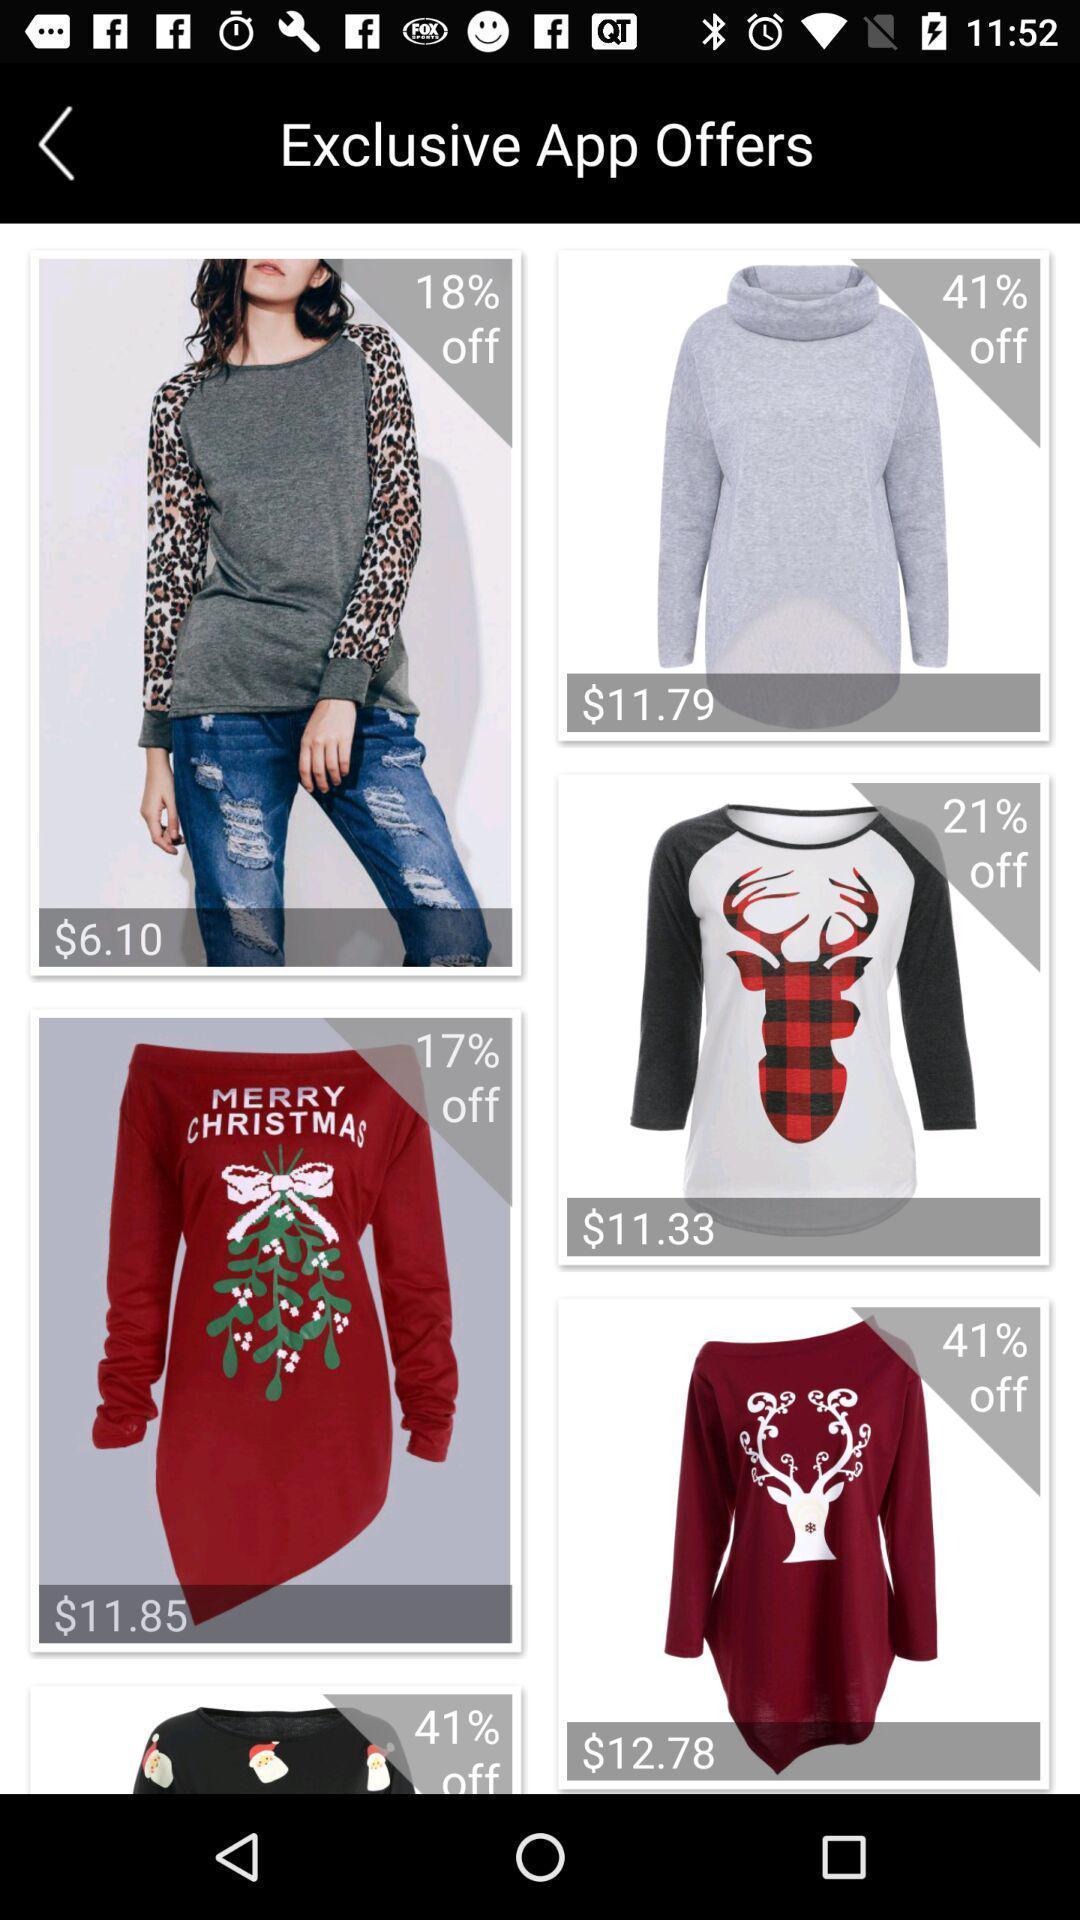What can you discern from this picture? Screen showing exclusive app offers. 